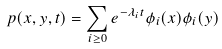Convert formula to latex. <formula><loc_0><loc_0><loc_500><loc_500>p ( x , y , t ) = \sum _ { i \geq 0 } e ^ { - \lambda _ { i } t } \phi _ { i } ( x ) \phi _ { i } ( y )</formula> 